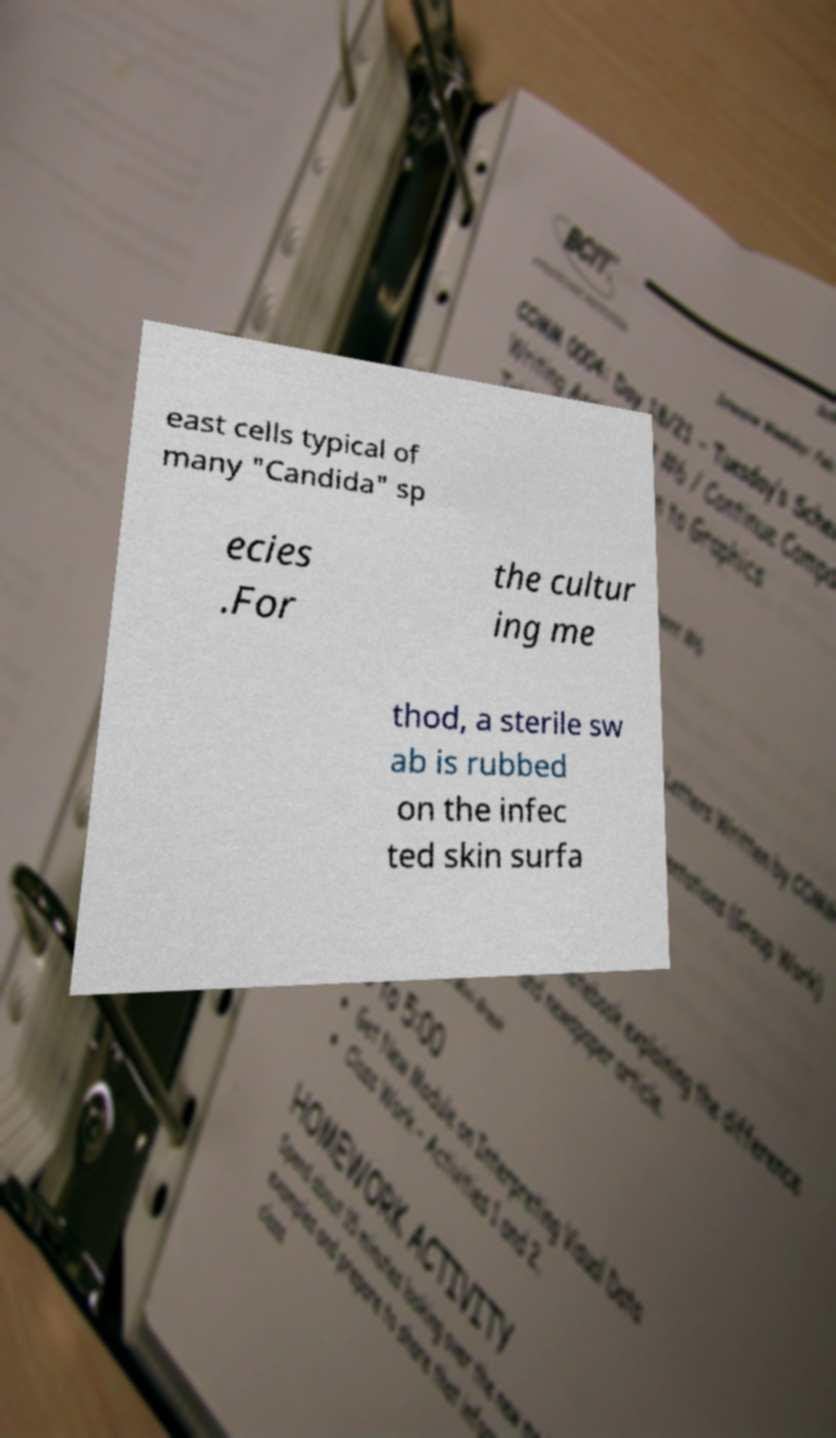Can you accurately transcribe the text from the provided image for me? east cells typical of many "Candida" sp ecies .For the cultur ing me thod, a sterile sw ab is rubbed on the infec ted skin surfa 